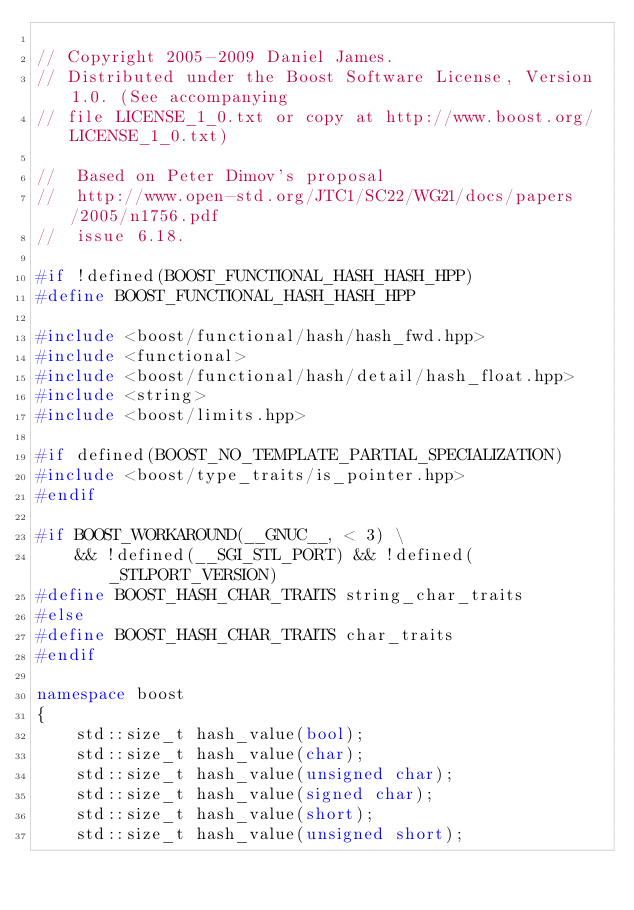Convert code to text. <code><loc_0><loc_0><loc_500><loc_500><_C++_>
// Copyright 2005-2009 Daniel James.
// Distributed under the Boost Software License, Version 1.0. (See accompanying
// file LICENSE_1_0.txt or copy at http://www.boost.org/LICENSE_1_0.txt)

//  Based on Peter Dimov's proposal
//  http://www.open-std.org/JTC1/SC22/WG21/docs/papers/2005/n1756.pdf
//  issue 6.18. 

#if !defined(BOOST_FUNCTIONAL_HASH_HASH_HPP)
#define BOOST_FUNCTIONAL_HASH_HASH_HPP

#include <boost/functional/hash/hash_fwd.hpp>
#include <functional>
#include <boost/functional/hash/detail/hash_float.hpp>
#include <string>
#include <boost/limits.hpp>

#if defined(BOOST_NO_TEMPLATE_PARTIAL_SPECIALIZATION)
#include <boost/type_traits/is_pointer.hpp>
#endif

#if BOOST_WORKAROUND(__GNUC__, < 3) \
    && !defined(__SGI_STL_PORT) && !defined(_STLPORT_VERSION)
#define BOOST_HASH_CHAR_TRAITS string_char_traits
#else
#define BOOST_HASH_CHAR_TRAITS char_traits
#endif

namespace boost
{
    std::size_t hash_value(bool);
    std::size_t hash_value(char);
    std::size_t hash_value(unsigned char);
    std::size_t hash_value(signed char);
    std::size_t hash_value(short);
    std::size_t hash_value(unsigned short);</code> 